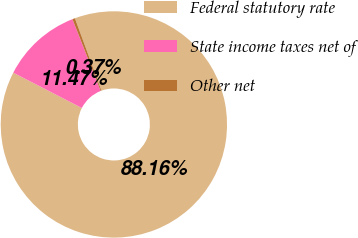Convert chart. <chart><loc_0><loc_0><loc_500><loc_500><pie_chart><fcel>Federal statutory rate<fcel>State income taxes net of<fcel>Other net<nl><fcel>88.16%<fcel>11.47%<fcel>0.37%<nl></chart> 